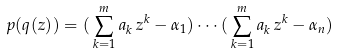<formula> <loc_0><loc_0><loc_500><loc_500>p ( q ( z ) ) = { ( } \sum _ { k = 1 } ^ { m } a _ { k } \, z ^ { k } - \alpha _ { 1 } { ) } \cdots { ( } \sum _ { k = 1 } ^ { m } a _ { k } \, z ^ { k } - \alpha _ { n } { ) }</formula> 